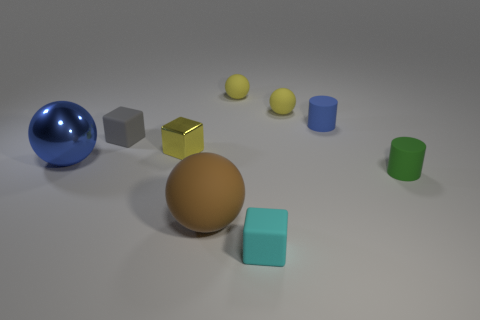Are there more tiny green matte things that are behind the green matte thing than tiny objects in front of the yellow metallic cube?
Give a very brief answer. No. What material is the small cylinder that is the same color as the large metal object?
Provide a succinct answer. Rubber. How many small cylinders have the same color as the big metallic object?
Your response must be concise. 1. There is a cube that is in front of the small metallic block; does it have the same color as the rubber cylinder that is behind the green rubber cylinder?
Your response must be concise. No. Are there any blue metal things on the right side of the yellow shiny thing?
Your answer should be very brief. No. What is the green object made of?
Ensure brevity in your answer.  Rubber. There is a big object that is in front of the small green rubber cylinder; what is its shape?
Provide a short and direct response. Sphere. What is the size of the cylinder that is the same color as the metal sphere?
Ensure brevity in your answer.  Small. Is there a gray matte thing of the same size as the cyan cube?
Keep it short and to the point. Yes. Is the material of the yellow thing in front of the tiny blue cylinder the same as the green cylinder?
Your answer should be compact. No. 